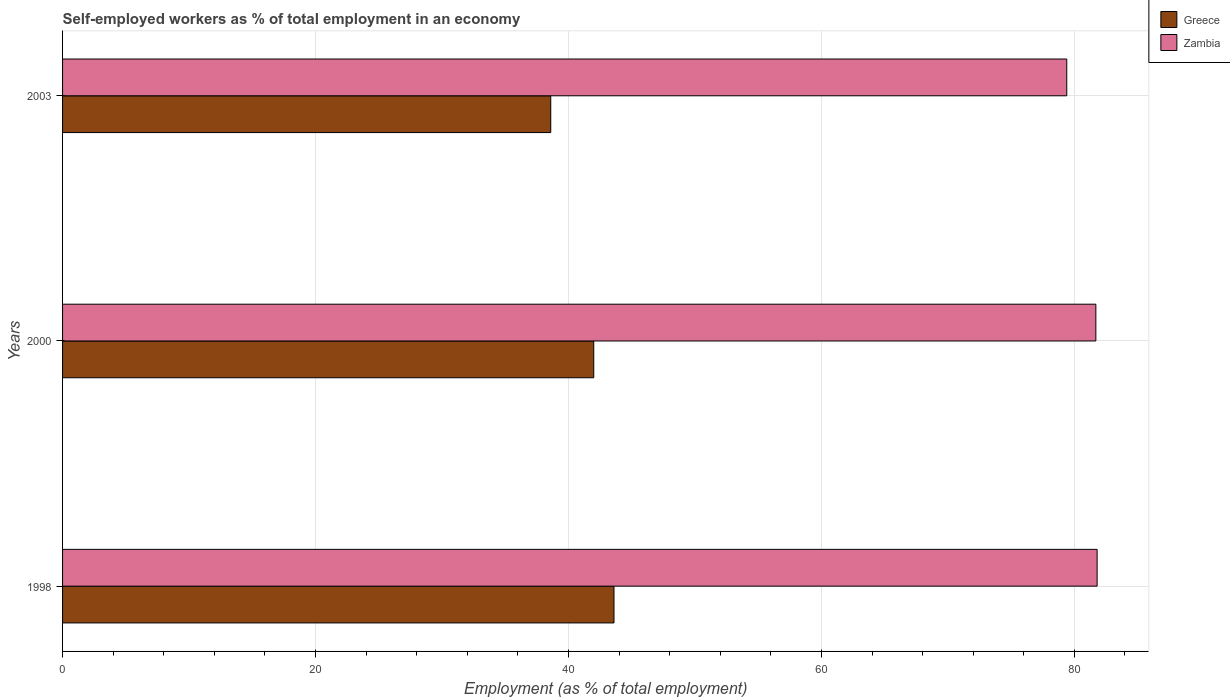How many different coloured bars are there?
Your response must be concise. 2. What is the percentage of self-employed workers in Greece in 2003?
Provide a short and direct response. 38.6. Across all years, what is the maximum percentage of self-employed workers in Zambia?
Your response must be concise. 81.8. Across all years, what is the minimum percentage of self-employed workers in Greece?
Offer a very short reply. 38.6. In which year was the percentage of self-employed workers in Greece maximum?
Give a very brief answer. 1998. In which year was the percentage of self-employed workers in Greece minimum?
Keep it short and to the point. 2003. What is the total percentage of self-employed workers in Zambia in the graph?
Your answer should be very brief. 242.9. What is the difference between the percentage of self-employed workers in Greece in 2000 and that in 2003?
Give a very brief answer. 3.4. What is the difference between the percentage of self-employed workers in Greece in 2000 and the percentage of self-employed workers in Zambia in 1998?
Offer a terse response. -39.8. What is the average percentage of self-employed workers in Greece per year?
Your answer should be compact. 41.4. In the year 1998, what is the difference between the percentage of self-employed workers in Zambia and percentage of self-employed workers in Greece?
Your answer should be compact. 38.2. In how many years, is the percentage of self-employed workers in Zambia greater than 24 %?
Make the answer very short. 3. What is the ratio of the percentage of self-employed workers in Zambia in 1998 to that in 2000?
Your response must be concise. 1. Is the percentage of self-employed workers in Zambia in 1998 less than that in 2003?
Your answer should be compact. No. Is the difference between the percentage of self-employed workers in Zambia in 1998 and 2000 greater than the difference between the percentage of self-employed workers in Greece in 1998 and 2000?
Ensure brevity in your answer.  No. What is the difference between the highest and the second highest percentage of self-employed workers in Greece?
Give a very brief answer. 1.6. What is the difference between the highest and the lowest percentage of self-employed workers in Zambia?
Your answer should be very brief. 2.4. Is the sum of the percentage of self-employed workers in Zambia in 2000 and 2003 greater than the maximum percentage of self-employed workers in Greece across all years?
Offer a terse response. Yes. What does the 1st bar from the top in 2003 represents?
Provide a succinct answer. Zambia. What does the 2nd bar from the bottom in 1998 represents?
Give a very brief answer. Zambia. Are all the bars in the graph horizontal?
Your response must be concise. Yes. Does the graph contain any zero values?
Ensure brevity in your answer.  No. Does the graph contain grids?
Make the answer very short. Yes. Where does the legend appear in the graph?
Offer a terse response. Top right. What is the title of the graph?
Keep it short and to the point. Self-employed workers as % of total employment in an economy. What is the label or title of the X-axis?
Your answer should be very brief. Employment (as % of total employment). What is the label or title of the Y-axis?
Make the answer very short. Years. What is the Employment (as % of total employment) in Greece in 1998?
Your answer should be very brief. 43.6. What is the Employment (as % of total employment) in Zambia in 1998?
Provide a succinct answer. 81.8. What is the Employment (as % of total employment) in Greece in 2000?
Provide a short and direct response. 42. What is the Employment (as % of total employment) of Zambia in 2000?
Offer a terse response. 81.7. What is the Employment (as % of total employment) of Greece in 2003?
Keep it short and to the point. 38.6. What is the Employment (as % of total employment) in Zambia in 2003?
Provide a succinct answer. 79.4. Across all years, what is the maximum Employment (as % of total employment) in Greece?
Offer a terse response. 43.6. Across all years, what is the maximum Employment (as % of total employment) in Zambia?
Your answer should be compact. 81.8. Across all years, what is the minimum Employment (as % of total employment) in Greece?
Your response must be concise. 38.6. Across all years, what is the minimum Employment (as % of total employment) in Zambia?
Give a very brief answer. 79.4. What is the total Employment (as % of total employment) in Greece in the graph?
Ensure brevity in your answer.  124.2. What is the total Employment (as % of total employment) of Zambia in the graph?
Keep it short and to the point. 242.9. What is the difference between the Employment (as % of total employment) in Greece in 1998 and that in 2003?
Give a very brief answer. 5. What is the difference between the Employment (as % of total employment) in Zambia in 1998 and that in 2003?
Give a very brief answer. 2.4. What is the difference between the Employment (as % of total employment) in Greece in 2000 and that in 2003?
Your response must be concise. 3.4. What is the difference between the Employment (as % of total employment) in Greece in 1998 and the Employment (as % of total employment) in Zambia in 2000?
Your answer should be very brief. -38.1. What is the difference between the Employment (as % of total employment) in Greece in 1998 and the Employment (as % of total employment) in Zambia in 2003?
Your answer should be compact. -35.8. What is the difference between the Employment (as % of total employment) in Greece in 2000 and the Employment (as % of total employment) in Zambia in 2003?
Provide a succinct answer. -37.4. What is the average Employment (as % of total employment) of Greece per year?
Offer a very short reply. 41.4. What is the average Employment (as % of total employment) of Zambia per year?
Provide a succinct answer. 80.97. In the year 1998, what is the difference between the Employment (as % of total employment) in Greece and Employment (as % of total employment) in Zambia?
Provide a succinct answer. -38.2. In the year 2000, what is the difference between the Employment (as % of total employment) in Greece and Employment (as % of total employment) in Zambia?
Offer a terse response. -39.7. In the year 2003, what is the difference between the Employment (as % of total employment) of Greece and Employment (as % of total employment) of Zambia?
Offer a very short reply. -40.8. What is the ratio of the Employment (as % of total employment) in Greece in 1998 to that in 2000?
Your answer should be very brief. 1.04. What is the ratio of the Employment (as % of total employment) of Zambia in 1998 to that in 2000?
Keep it short and to the point. 1. What is the ratio of the Employment (as % of total employment) of Greece in 1998 to that in 2003?
Ensure brevity in your answer.  1.13. What is the ratio of the Employment (as % of total employment) of Zambia in 1998 to that in 2003?
Your response must be concise. 1.03. What is the ratio of the Employment (as % of total employment) in Greece in 2000 to that in 2003?
Provide a short and direct response. 1.09. What is the difference between the highest and the lowest Employment (as % of total employment) in Zambia?
Offer a terse response. 2.4. 